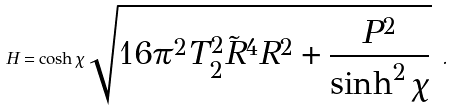Convert formula to latex. <formula><loc_0><loc_0><loc_500><loc_500>H = \cosh \chi \sqrt { 1 6 \pi ^ { 2 } T _ { 2 } ^ { 2 } \tilde { R } ^ { 4 } R ^ { 2 } + \frac { P ^ { 2 } } { \sinh ^ { 2 } \chi } } \ .</formula> 